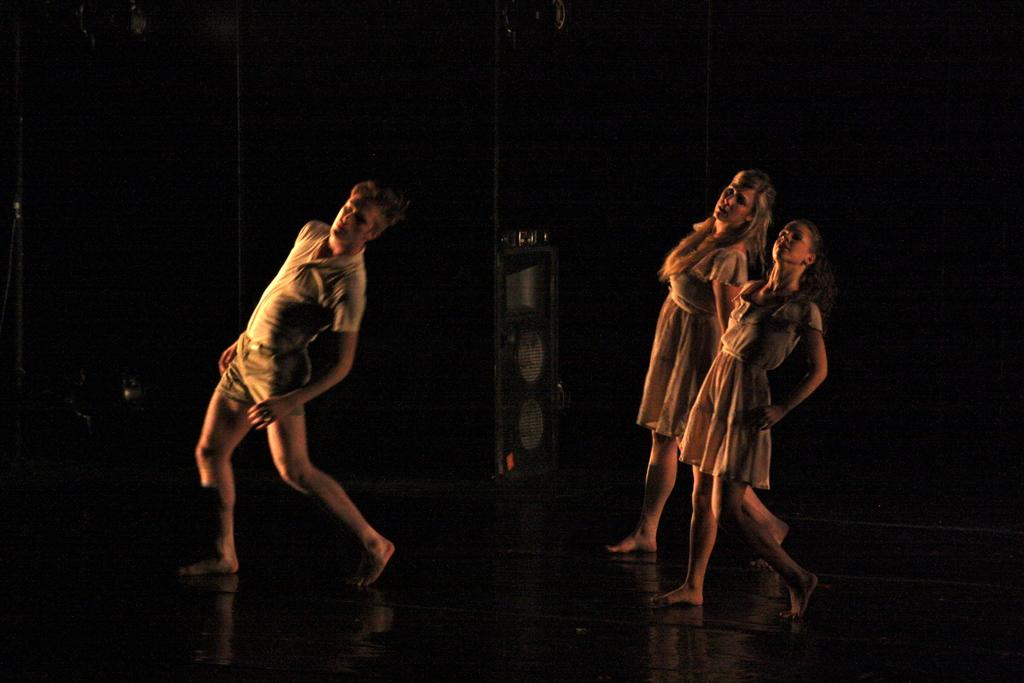What is the overall appearance of the image? The image has a dark appearance. What color is the floor in the image? There is a black colored floor in the image. What are the persons wearing in the image? The persons are wearing brown colored dresses in the image. Where are the persons standing in the image? The persons are standing on the floor in the image. How would you describe the background of the image? The background of the image is dark. What type of song is being sung by the persons in the image? There is no indication in the image that the persons are singing a song, so it cannot be determined from the picture. 